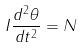<formula> <loc_0><loc_0><loc_500><loc_500>I \frac { d ^ { 2 } \theta } { d t ^ { 2 } } = N</formula> 